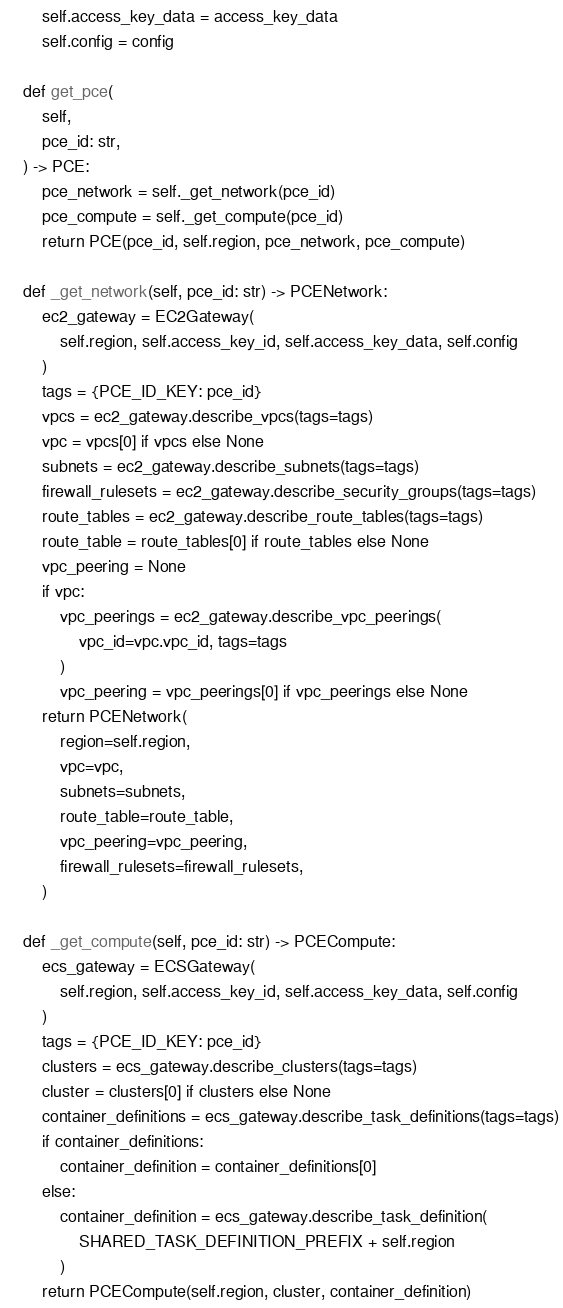<code> <loc_0><loc_0><loc_500><loc_500><_Python_>        self.access_key_data = access_key_data
        self.config = config

    def get_pce(
        self,
        pce_id: str,
    ) -> PCE:
        pce_network = self._get_network(pce_id)
        pce_compute = self._get_compute(pce_id)
        return PCE(pce_id, self.region, pce_network, pce_compute)

    def _get_network(self, pce_id: str) -> PCENetwork:
        ec2_gateway = EC2Gateway(
            self.region, self.access_key_id, self.access_key_data, self.config
        )
        tags = {PCE_ID_KEY: pce_id}
        vpcs = ec2_gateway.describe_vpcs(tags=tags)
        vpc = vpcs[0] if vpcs else None
        subnets = ec2_gateway.describe_subnets(tags=tags)
        firewall_rulesets = ec2_gateway.describe_security_groups(tags=tags)
        route_tables = ec2_gateway.describe_route_tables(tags=tags)
        route_table = route_tables[0] if route_tables else None
        vpc_peering = None
        if vpc:
            vpc_peerings = ec2_gateway.describe_vpc_peerings(
                vpc_id=vpc.vpc_id, tags=tags
            )
            vpc_peering = vpc_peerings[0] if vpc_peerings else None
        return PCENetwork(
            region=self.region,
            vpc=vpc,
            subnets=subnets,
            route_table=route_table,
            vpc_peering=vpc_peering,
            firewall_rulesets=firewall_rulesets,
        )

    def _get_compute(self, pce_id: str) -> PCECompute:
        ecs_gateway = ECSGateway(
            self.region, self.access_key_id, self.access_key_data, self.config
        )
        tags = {PCE_ID_KEY: pce_id}
        clusters = ecs_gateway.describe_clusters(tags=tags)
        cluster = clusters[0] if clusters else None
        container_definitions = ecs_gateway.describe_task_definitions(tags=tags)
        if container_definitions:
            container_definition = container_definitions[0]
        else:
            container_definition = ecs_gateway.describe_task_definition(
                SHARED_TASK_DEFINITION_PREFIX + self.region
            )
        return PCECompute(self.region, cluster, container_definition)
</code> 